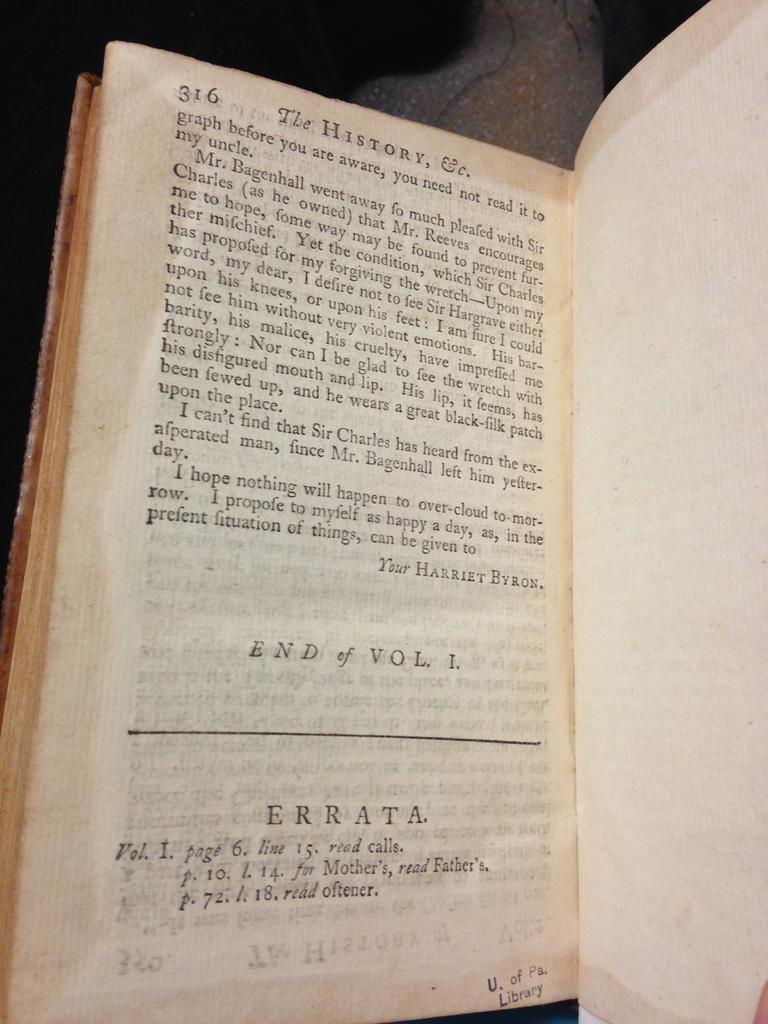<image>
Offer a succinct explanation of the picture presented. A book from U. of Pa. Library opened up to page 316. 